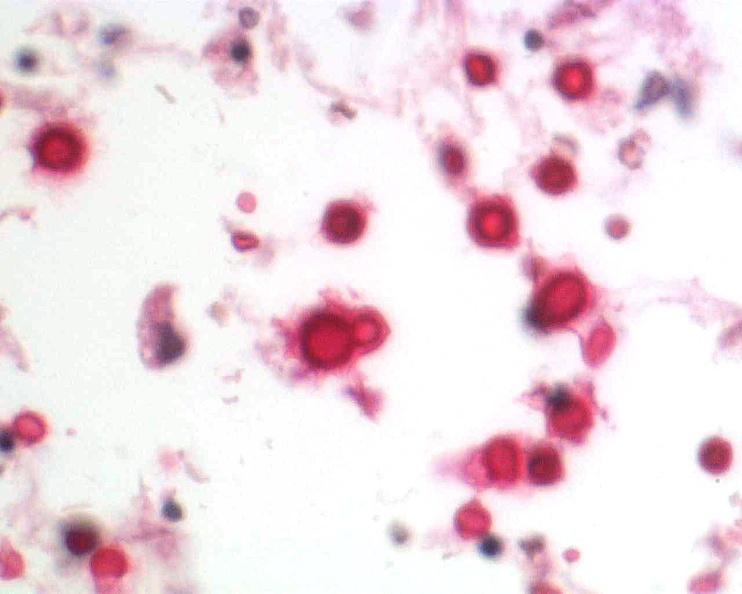what stain?
Answer the question using a single word or phrase. Mucicarmine 